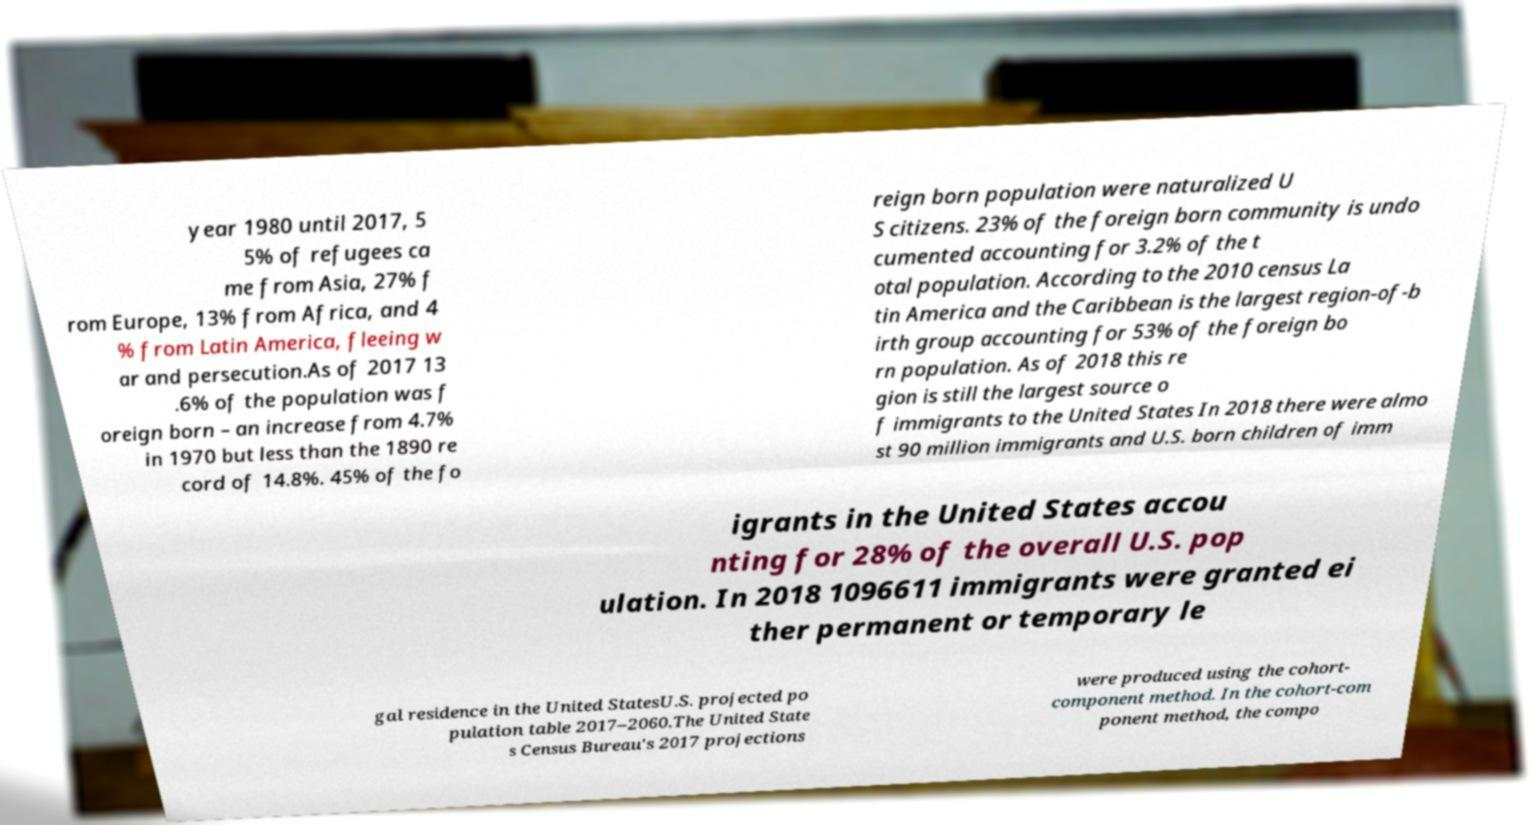There's text embedded in this image that I need extracted. Can you transcribe it verbatim? year 1980 until 2017, 5 5% of refugees ca me from Asia, 27% f rom Europe, 13% from Africa, and 4 % from Latin America, fleeing w ar and persecution.As of 2017 13 .6% of the population was f oreign born – an increase from 4.7% in 1970 but less than the 1890 re cord of 14.8%. 45% of the fo reign born population were naturalized U S citizens. 23% of the foreign born community is undo cumented accounting for 3.2% of the t otal population. According to the 2010 census La tin America and the Caribbean is the largest region-of-b irth group accounting for 53% of the foreign bo rn population. As of 2018 this re gion is still the largest source o f immigrants to the United States In 2018 there were almo st 90 million immigrants and U.S. born children of imm igrants in the United States accou nting for 28% of the overall U.S. pop ulation. In 2018 1096611 immigrants were granted ei ther permanent or temporary le gal residence in the United StatesU.S. projected po pulation table 2017–2060.The United State s Census Bureau's 2017 projections were produced using the cohort- component method. In the cohort-com ponent method, the compo 